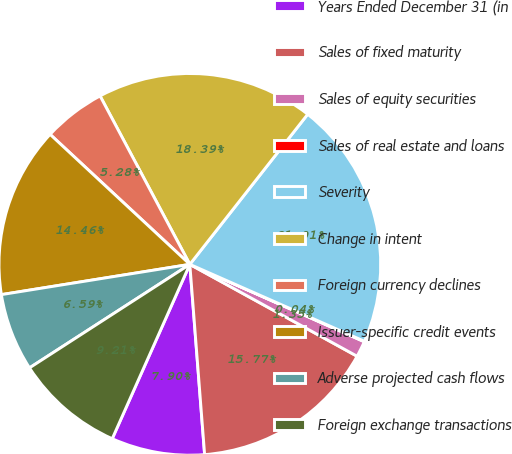Convert chart to OTSL. <chart><loc_0><loc_0><loc_500><loc_500><pie_chart><fcel>Years Ended December 31 (in<fcel>Sales of fixed maturity<fcel>Sales of equity securities<fcel>Sales of real estate and loans<fcel>Severity<fcel>Change in intent<fcel>Foreign currency declines<fcel>Issuer-specific credit events<fcel>Adverse projected cash flows<fcel>Foreign exchange transactions<nl><fcel>7.9%<fcel>15.77%<fcel>1.35%<fcel>0.04%<fcel>21.01%<fcel>18.39%<fcel>5.28%<fcel>14.46%<fcel>6.59%<fcel>9.21%<nl></chart> 